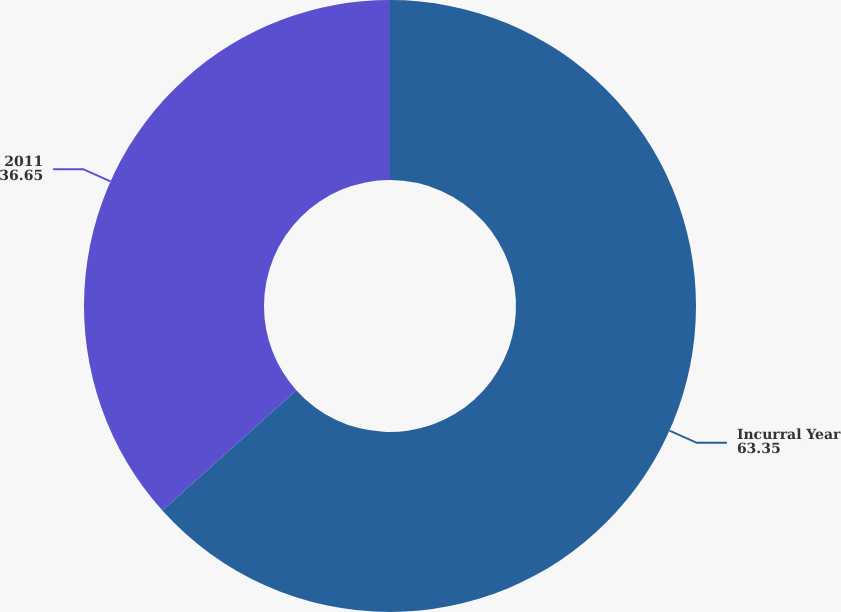Convert chart to OTSL. <chart><loc_0><loc_0><loc_500><loc_500><pie_chart><fcel>Incurral Year<fcel>2011<nl><fcel>63.35%<fcel>36.65%<nl></chart> 